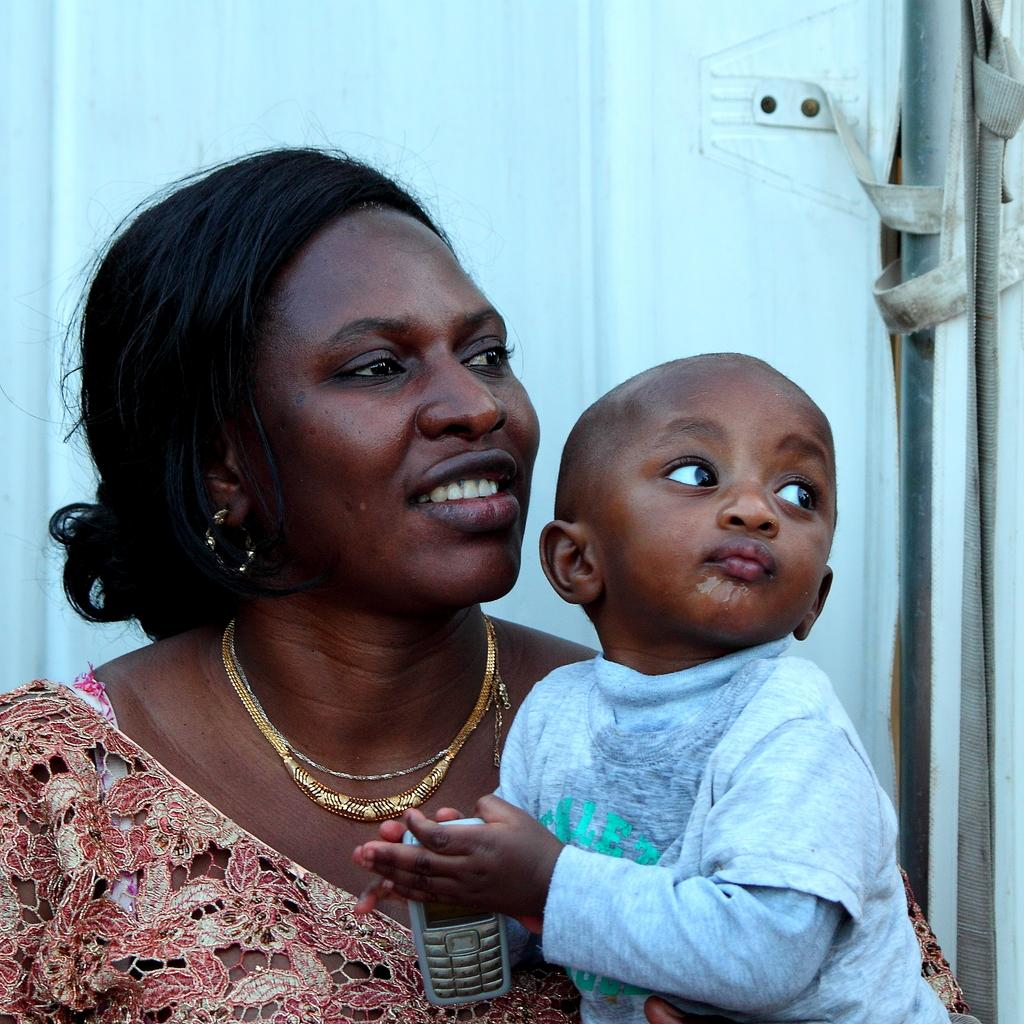Who is present in the image? There is a woman and a small baby in the image. Where are the woman and baby located in the image? They are in the foreground of the image. What can be seen in the background of the image? There is a pole in the background of the image. What type of weather can be seen in the image? There is no information about the weather in the image; it only shows a woman, a baby, and a pole. How many rods are visible in the image? There is no rod present in the image; only a pole can be seen in the background. 